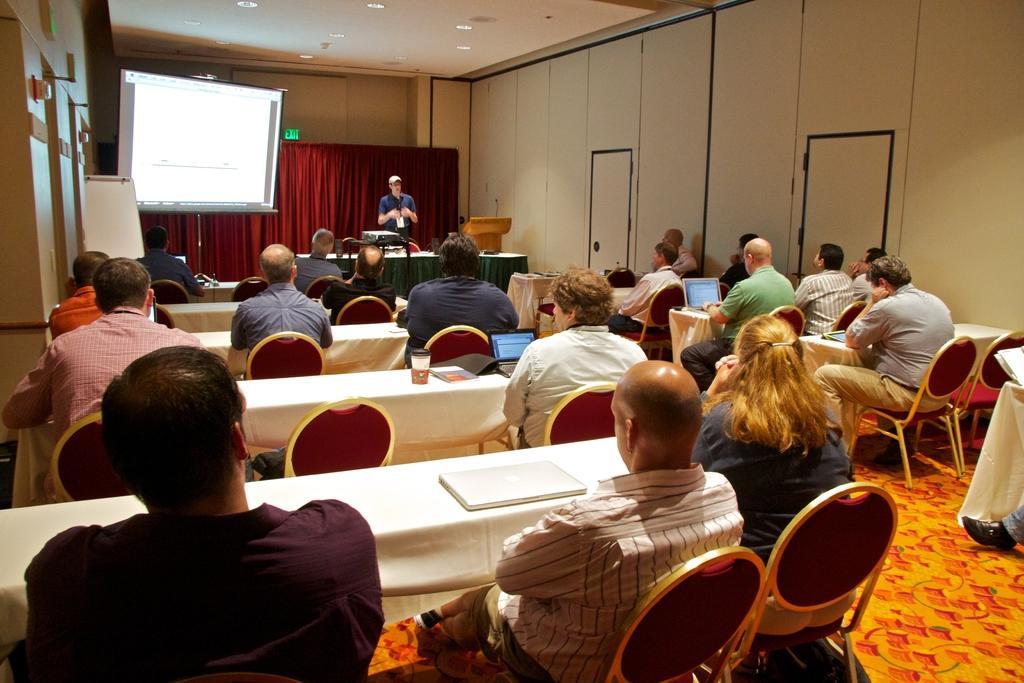Could you give a brief overview of what you see in this image? The picture of few people sat on chairs in front of table and this room seems to be conference hall and over the background there is a man stood beside a projector screen and behind him there is a curtain. 